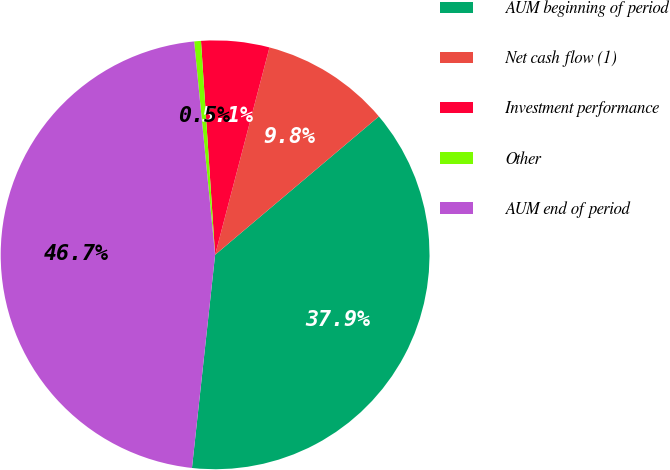Convert chart to OTSL. <chart><loc_0><loc_0><loc_500><loc_500><pie_chart><fcel>AUM beginning of period<fcel>Net cash flow (1)<fcel>Investment performance<fcel>Other<fcel>AUM end of period<nl><fcel>37.88%<fcel>9.75%<fcel>5.13%<fcel>0.51%<fcel>46.71%<nl></chart> 